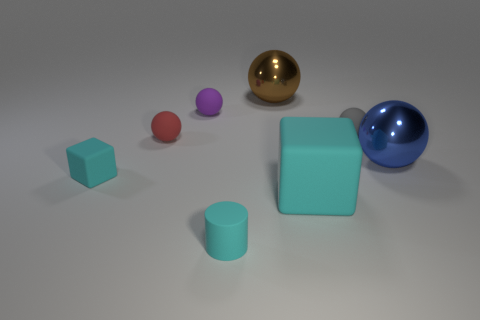Subtract all matte spheres. How many spheres are left? 2 Add 2 big blue shiny spheres. How many objects exist? 10 Subtract all brown spheres. How many spheres are left? 4 Subtract all balls. How many objects are left? 3 Subtract all brown balls. How many blue blocks are left? 0 Subtract all cylinders. Subtract all metal objects. How many objects are left? 5 Add 7 shiny things. How many shiny things are left? 9 Add 4 tiny red things. How many tiny red things exist? 5 Subtract 1 cyan cylinders. How many objects are left? 7 Subtract 2 blocks. How many blocks are left? 0 